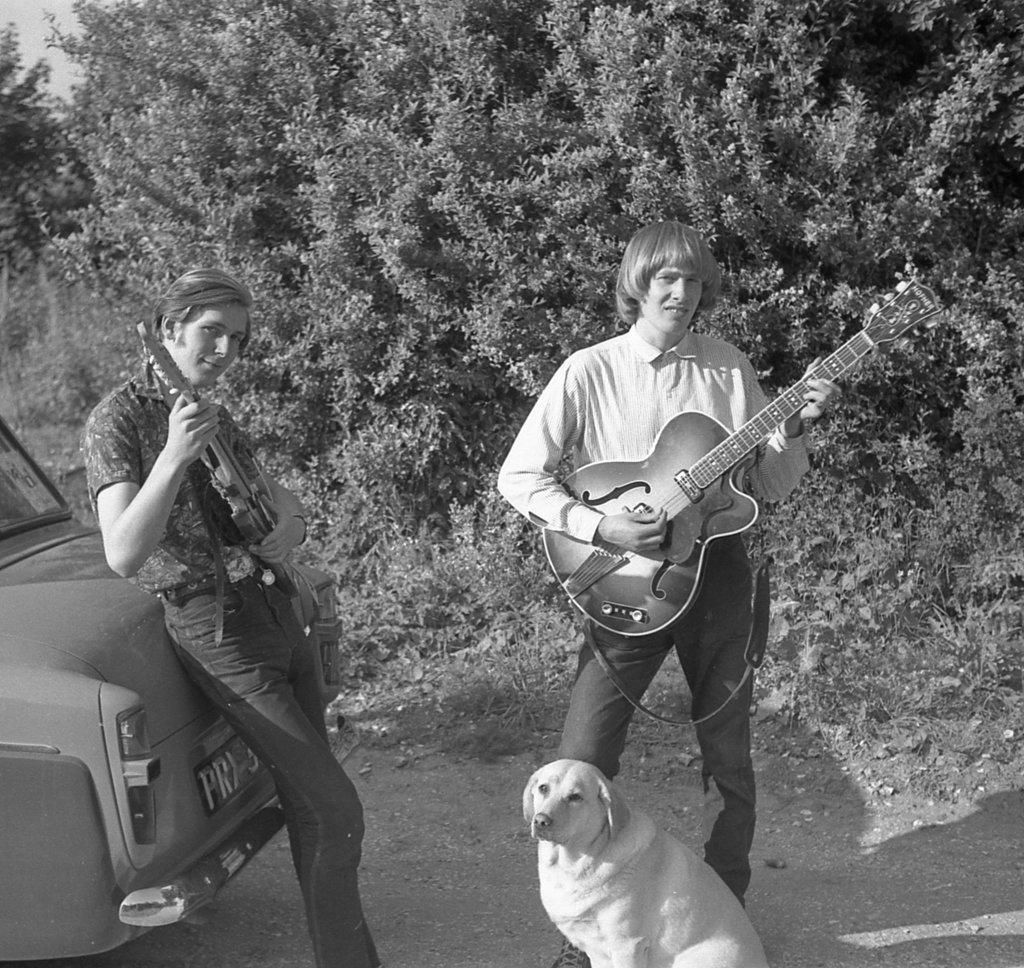How many people are in the image? There are two persons in the image. What are the persons holding in the image? The persons are holding guitars. What can be seen on the left side of the image? There is a car on the left side of the image. What type of animal is visible in the image? There is a dog visible in the image. What is visible in the background of the image? Trees are present in the background of the image. What type of structure does the beginner governor build in the image? There is no mention of a structure, beginner, or governor in the image. 